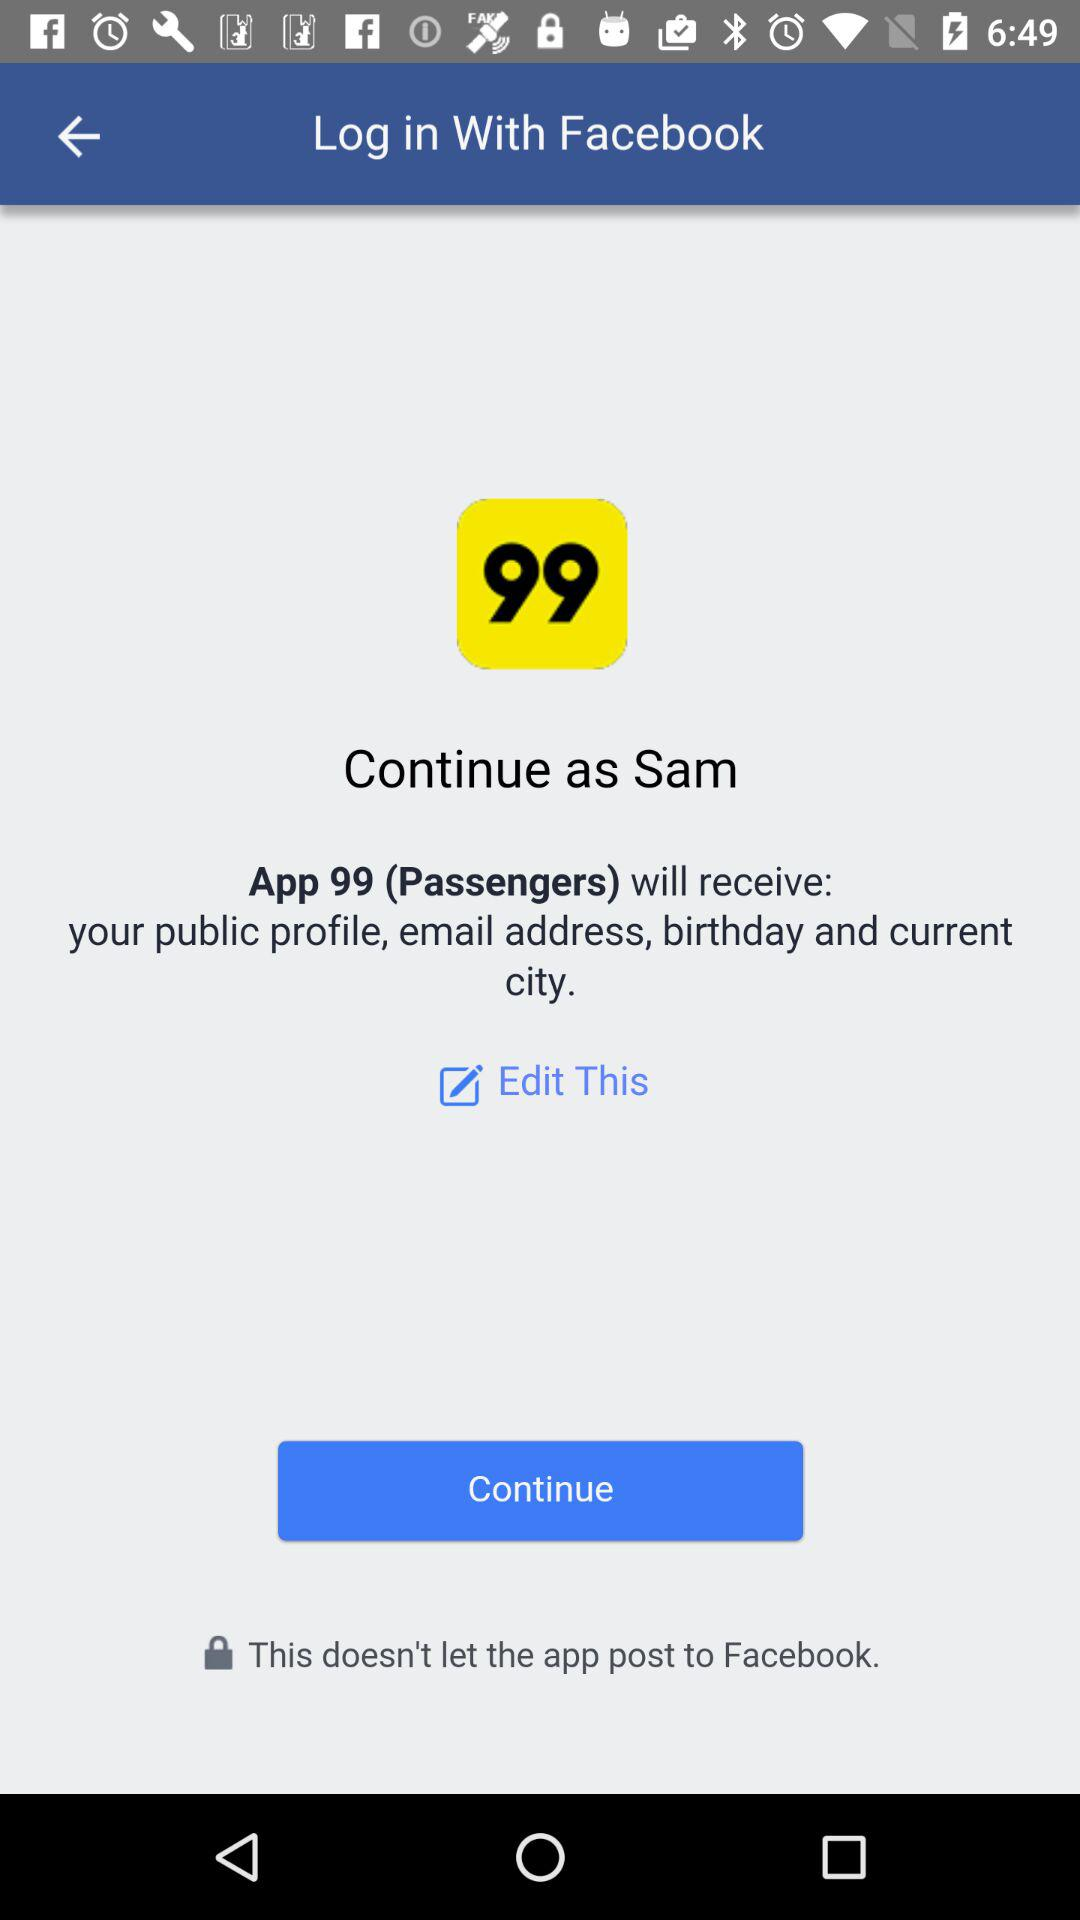What application are we accessing? You are accessing "App 99 (Passengers)". 